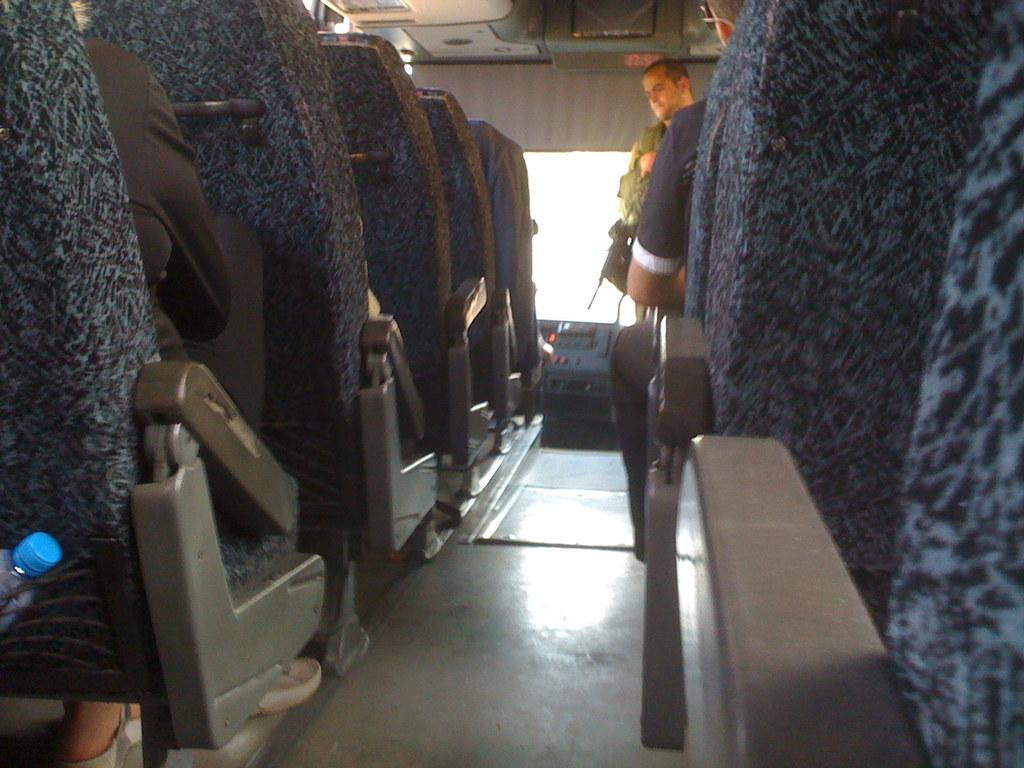Where was the image taken? The image was taken inside a bus. What can be seen in the center of the image? There is a man standing in the center of the image. What are the seats in the bus used for? The seats in the bus are used for passengers to sit. Are there any people sitting in the seats? Yes, people are sitting in the seats. What object is on the left side of the image? There is a bottle on the left side of the image. What type of curve can be seen in the image? There is no curve visible in the image; it is taken inside a bus. Can you tell me how many cellars are present in the image? There are no cellars present in the image; it is taken inside a bus. 